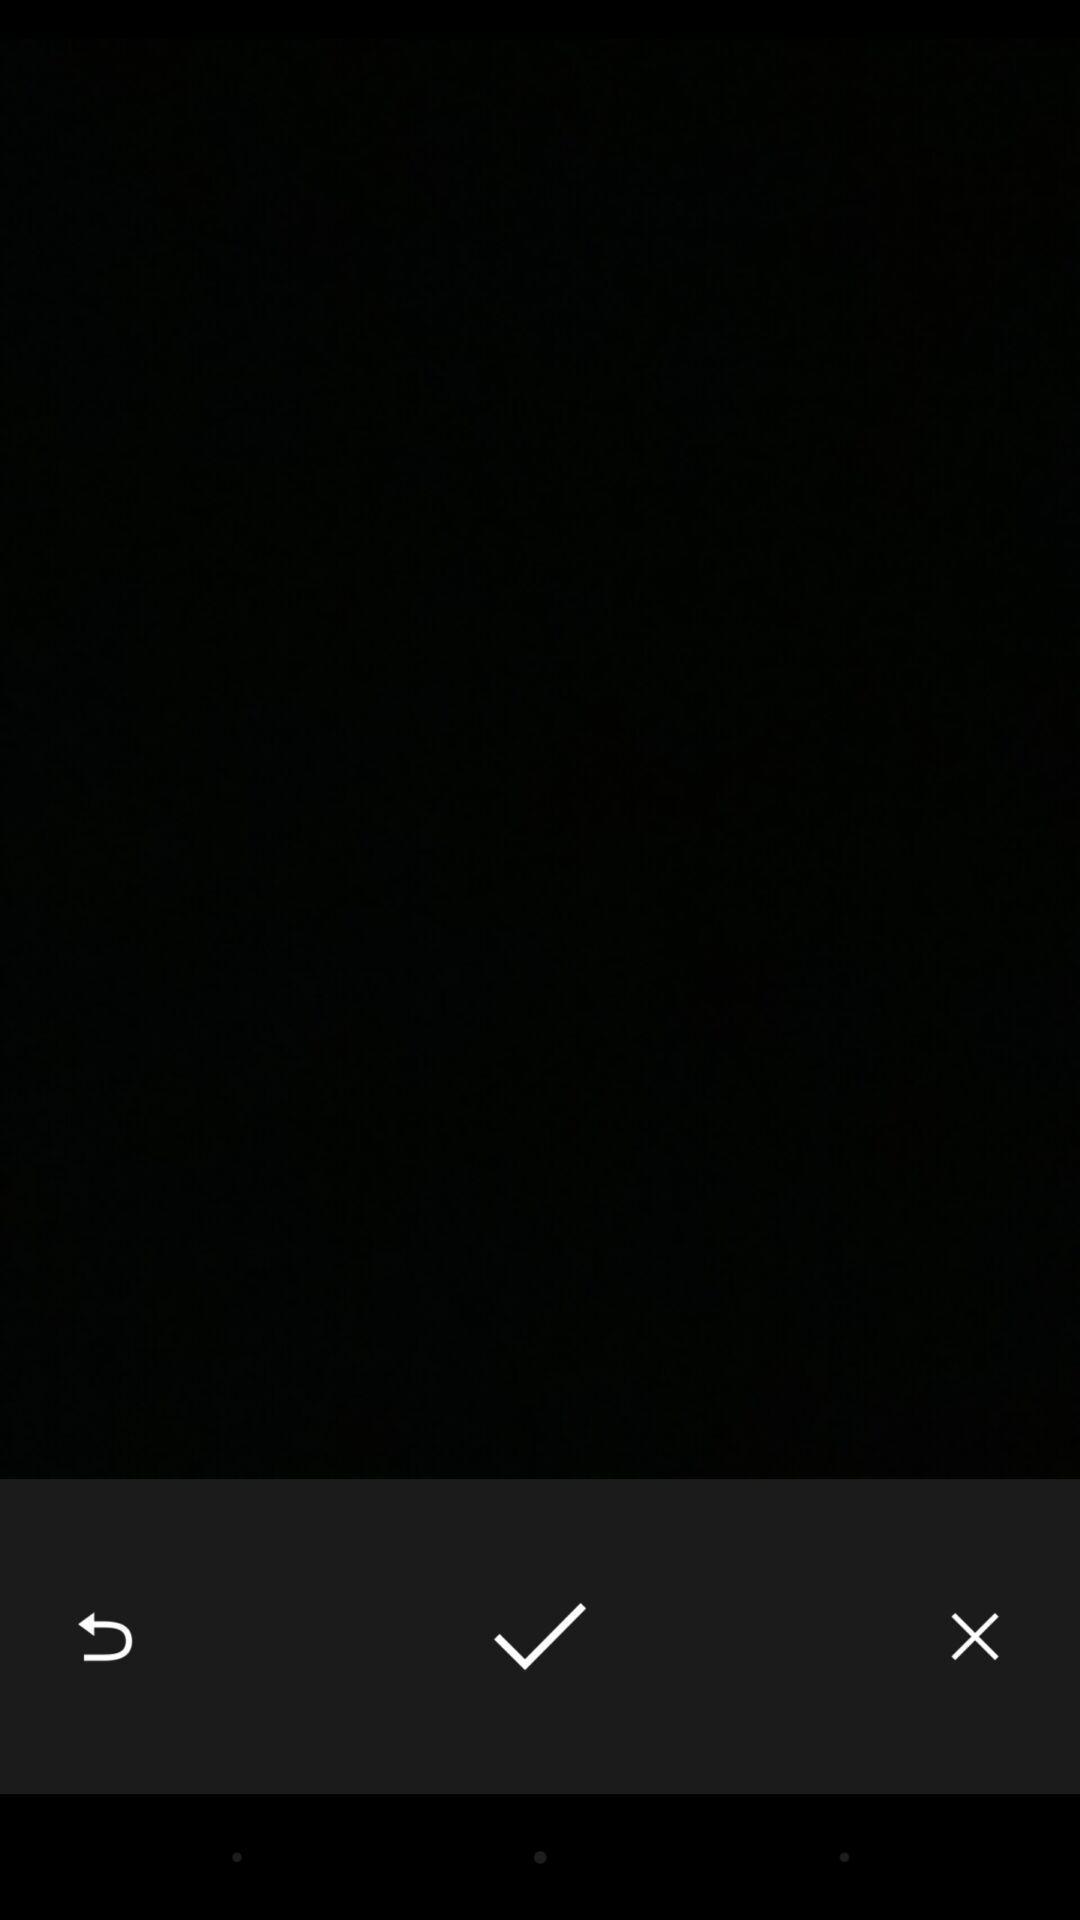Summarize the information in this screenshot. Page shows blank screen. 